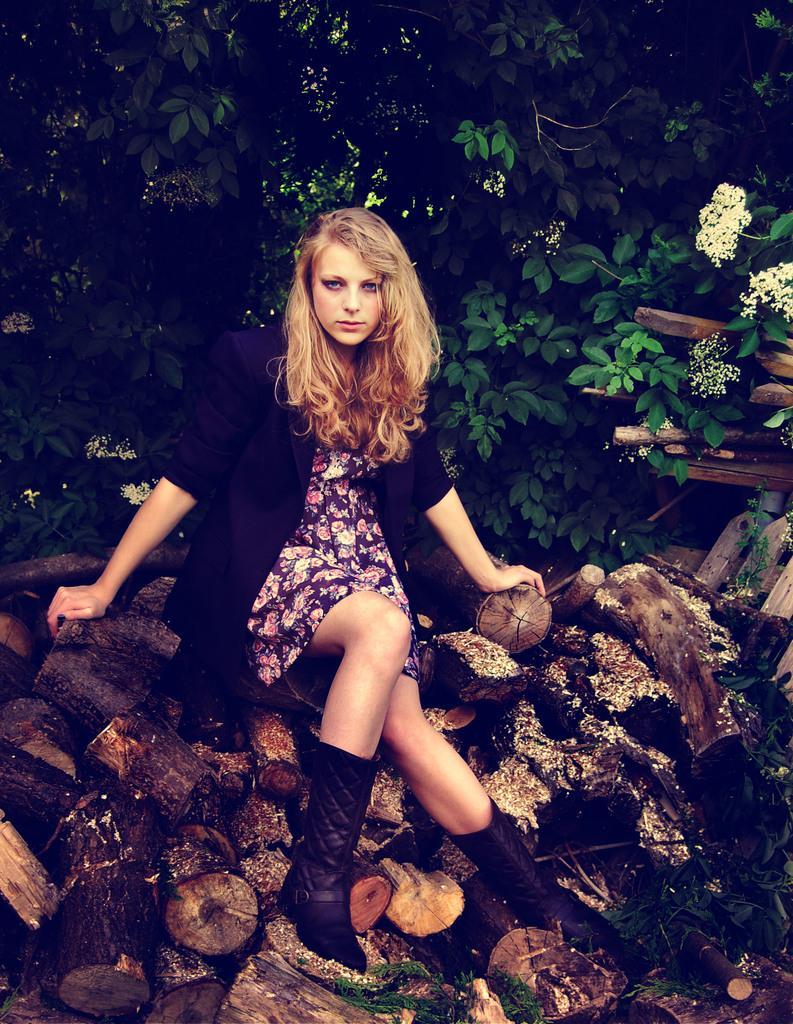Describe this image in one or two sentences. In this image, we can see a person sitting on cut woods. There is a tree at the top of the image. 